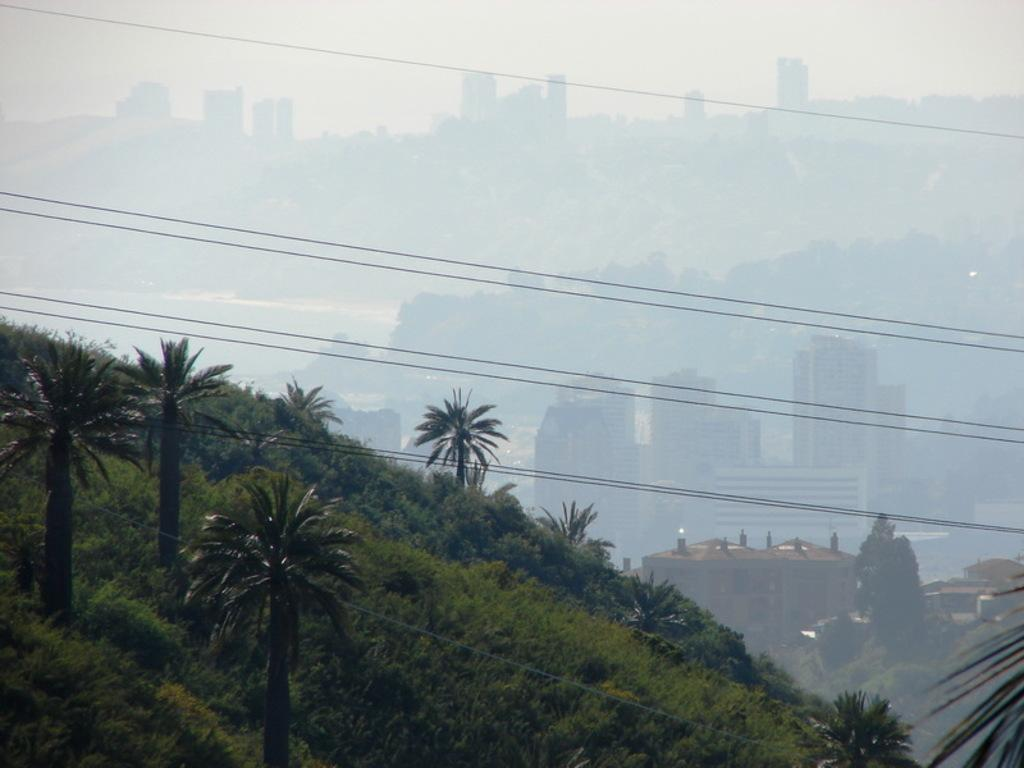What geographical feature is present in the image? There is a hill in the image. What can be found on the hill? There are trees and plants on the hill. What structures can be seen in the distance? There are buildings in the background of the image. What is visible at the top of the image? The sky is visible at the top of the image. What else is present in the air? There are cable wires in the air. What color is the zephyr in the image? There is no zephyr present in the image. A zephyr is a gentle breeze, and it does not have a color. 